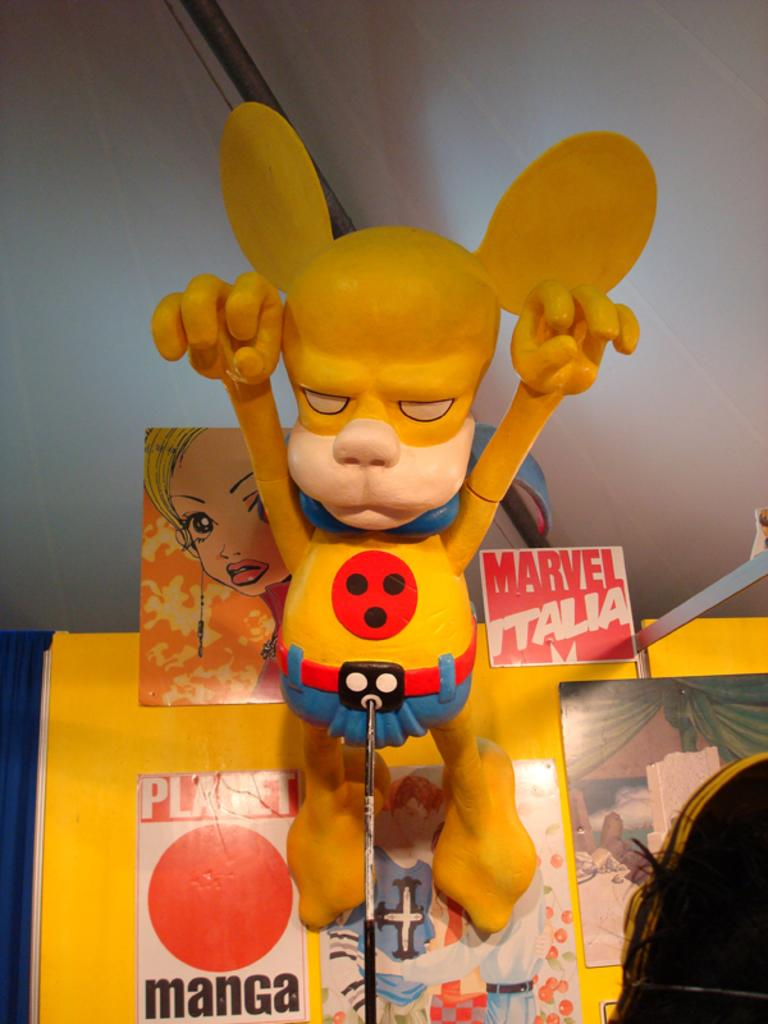What type of object can be seen in the image? There is a toy in the image. How is the toy supported or held up? The toy has a stand. What can be seen in the background of the image? There are boards and a wall visible in the image. What other object can be seen in the image? There is a rod in the image. Can you describe any other objects in the image? There are other unspecified objects in the image. What type of powder can be seen on the toy in the image? There is no powder visible on the toy in the image. How much weight can the rod in the image support? The weight capacity of the rod cannot be determined from the image alone. 